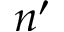Convert formula to latex. <formula><loc_0><loc_0><loc_500><loc_500>n ^ { \prime }</formula> 